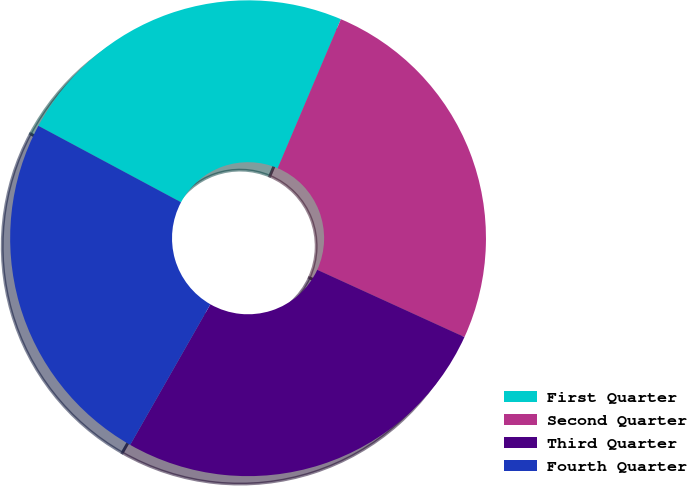<chart> <loc_0><loc_0><loc_500><loc_500><pie_chart><fcel>First Quarter<fcel>Second Quarter<fcel>Third Quarter<fcel>Fourth Quarter<nl><fcel>23.55%<fcel>25.44%<fcel>26.43%<fcel>24.58%<nl></chart> 